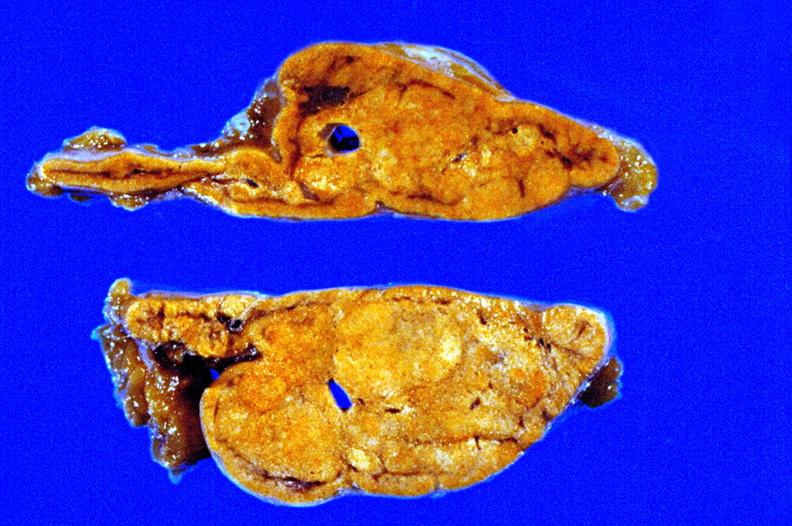how is fixed tissue cut surface close-up view rather good apparently non-?
Answer the question using a single word or phrase. Functional 